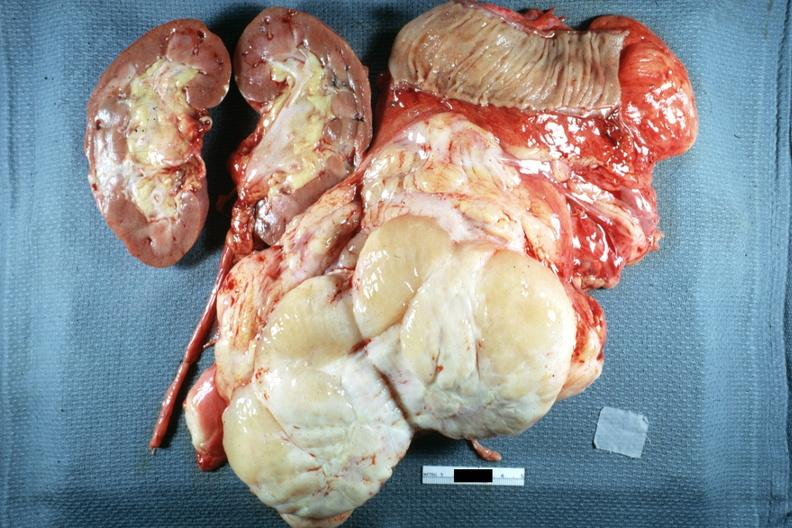s retroperitoneal liposarcoma present?
Answer the question using a single word or phrase. Yes 